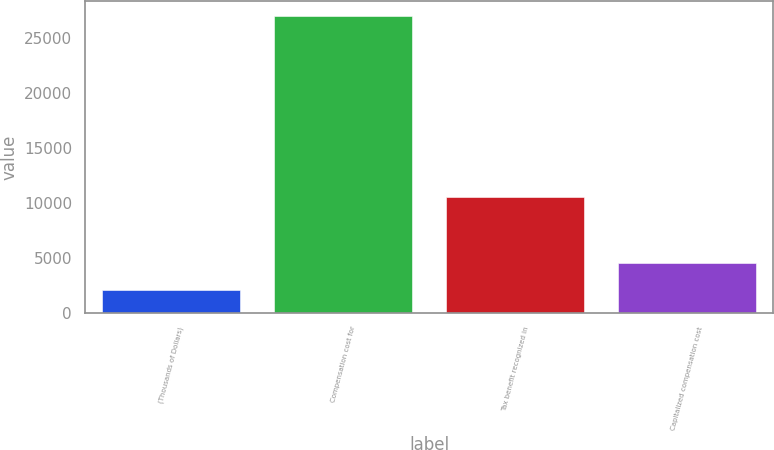Convert chart. <chart><loc_0><loc_0><loc_500><loc_500><bar_chart><fcel>(Thousands of Dollars)<fcel>Compensation cost for<fcel>Tax benefit recognized in<fcel>Capitalized compensation cost<nl><fcel>2012<fcel>26970<fcel>10513<fcel>4507.8<nl></chart> 